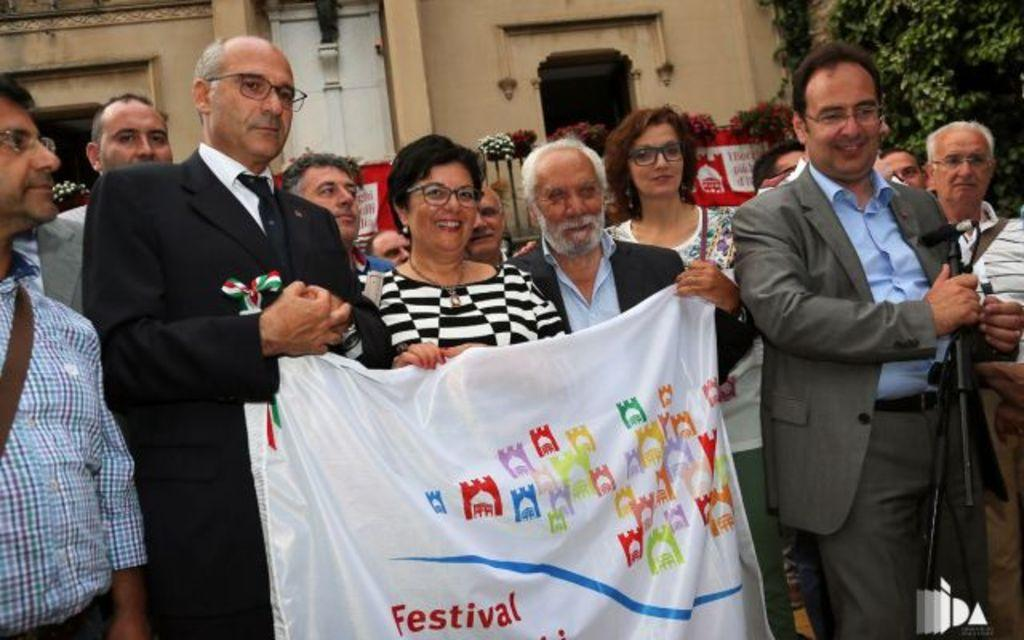What are the people in the image doing? The people in the image are standing and holding a white banner. What can be seen in the background of the image? There are buildings and trees in the background of the image. What type of plate is being used to serve food in the image? There is no plate or food present in the image; it features people holding a white banner with buildings and trees in the background. 